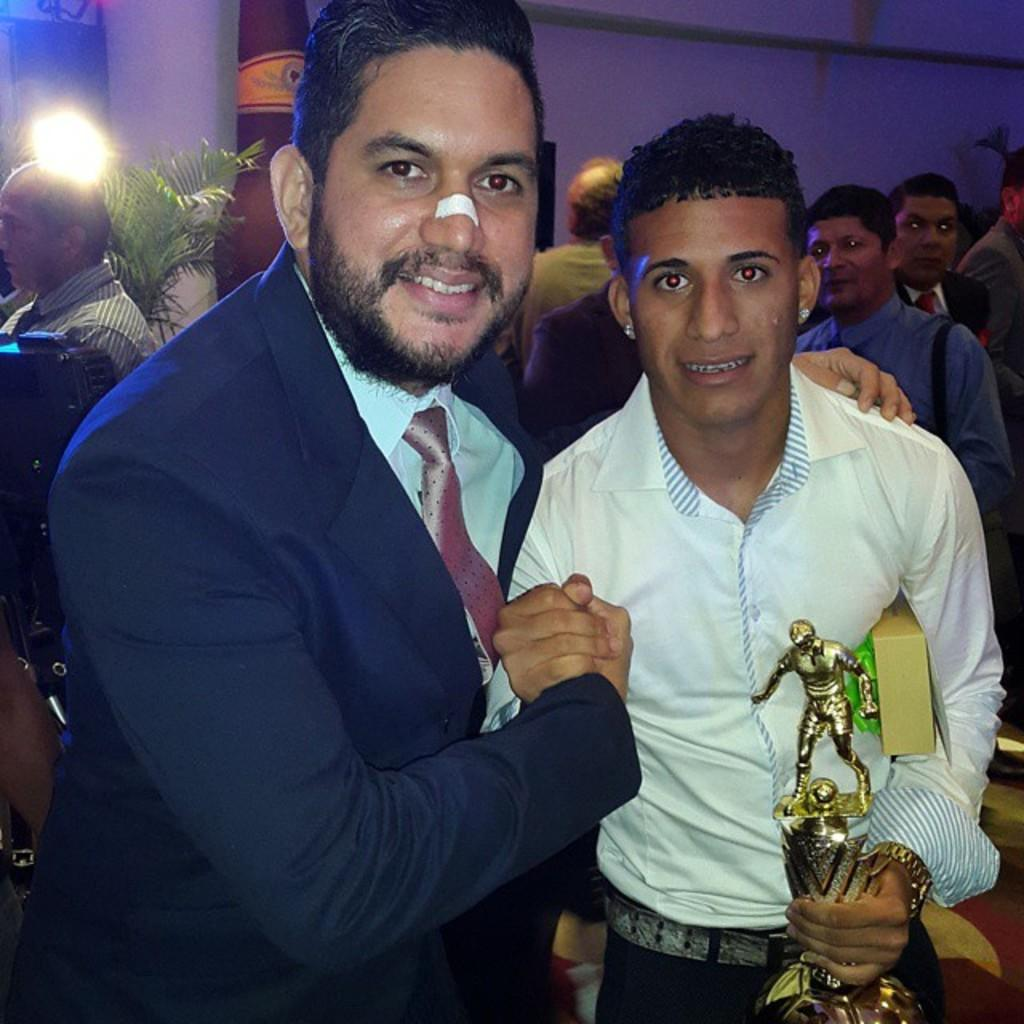How many people are in the image? There is a group of people in the image. Can you describe the expressions of any of the people? Two men are smiling in the image. What is the man holding in the image? A man is holding a trophy in the image. What can be seen in the background of the image? There is a tree and a wall in the background of the image. What type of clouds are present in the image? There are no clouds visible in the image; only a tree and a wall can be seen in the background. 